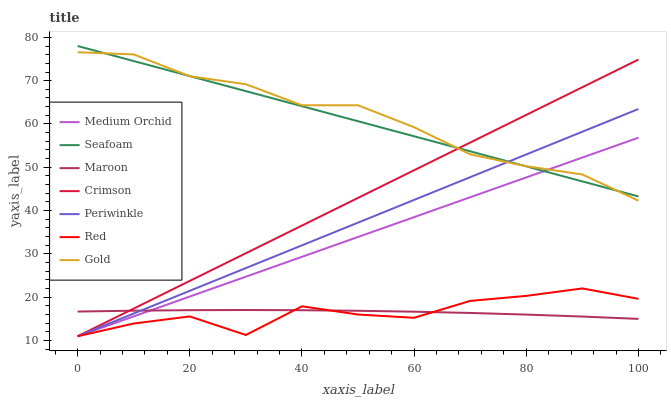Does Medium Orchid have the minimum area under the curve?
Answer yes or no. No. Does Medium Orchid have the maximum area under the curve?
Answer yes or no. No. Is Seafoam the smoothest?
Answer yes or no. No. Is Seafoam the roughest?
Answer yes or no. No. Does Seafoam have the lowest value?
Answer yes or no. No. Does Medium Orchid have the highest value?
Answer yes or no. No. Is Red less than Gold?
Answer yes or no. Yes. Is Seafoam greater than Maroon?
Answer yes or no. Yes. Does Red intersect Gold?
Answer yes or no. No. 